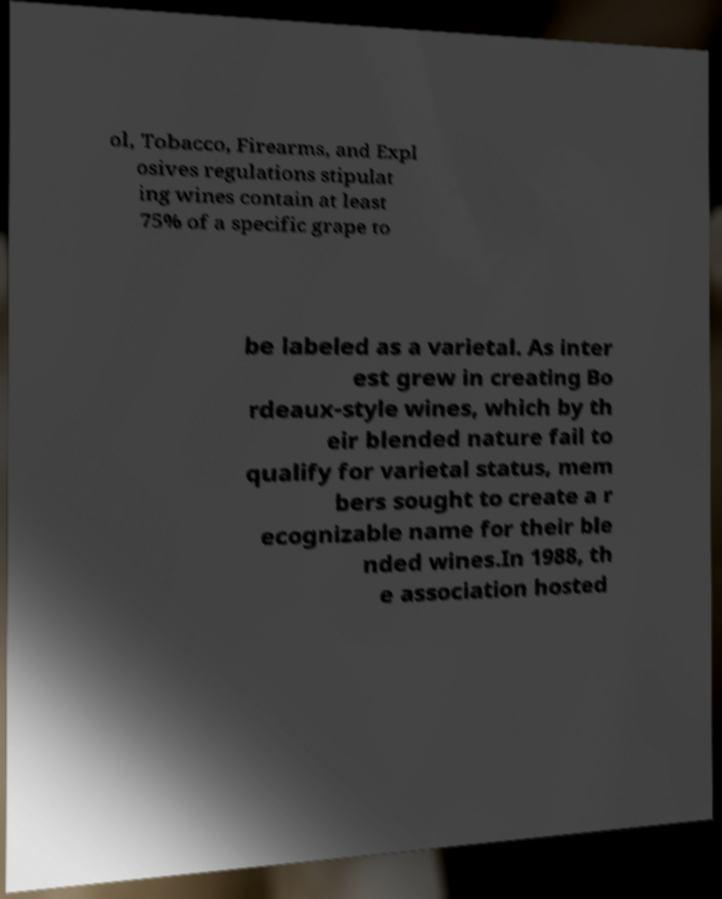There's text embedded in this image that I need extracted. Can you transcribe it verbatim? ol, Tobacco, Firearms, and Expl osives regulations stipulat ing wines contain at least 75% of a specific grape to be labeled as a varietal. As inter est grew in creating Bo rdeaux-style wines, which by th eir blended nature fail to qualify for varietal status, mem bers sought to create a r ecognizable name for their ble nded wines.In 1988, th e association hosted 